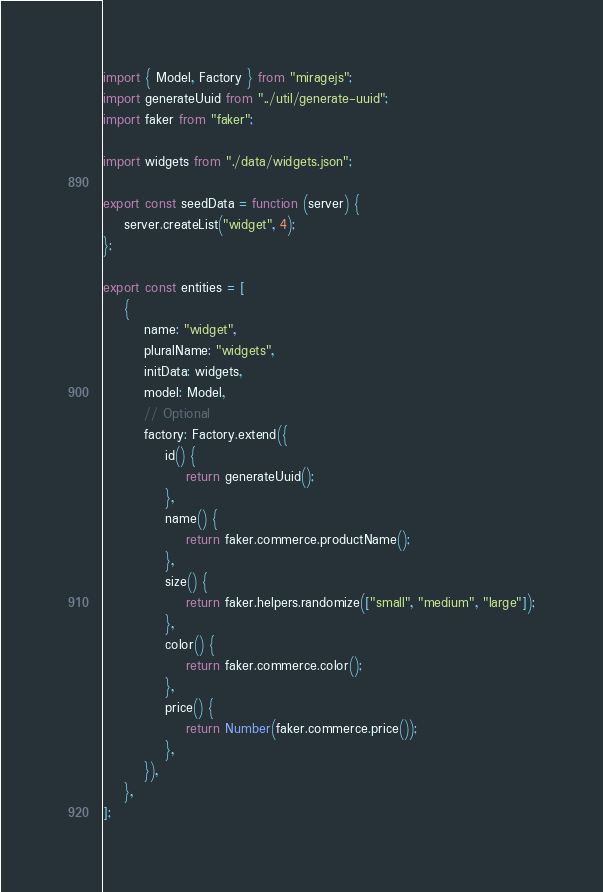<code> <loc_0><loc_0><loc_500><loc_500><_JavaScript_>import { Model, Factory } from "miragejs";
import generateUuid from "../util/generate-uuid";
import faker from "faker";

import widgets from "./data/widgets.json";

export const seedData = function (server) {
    server.createList("widget", 4);
};

export const entities = [
    {
        name: "widget",
        pluralName: "widgets",
        initData: widgets,
        model: Model,
        // Optional
        factory: Factory.extend({
            id() {
                return generateUuid();
            },
            name() {
                return faker.commerce.productName();
            },
            size() {
                return faker.helpers.randomize(["small", "medium", "large"]);
            },
            color() {
                return faker.commerce.color();
            },
            price() {
                return Number(faker.commerce.price());
            },
        }),
    },
];
</code> 